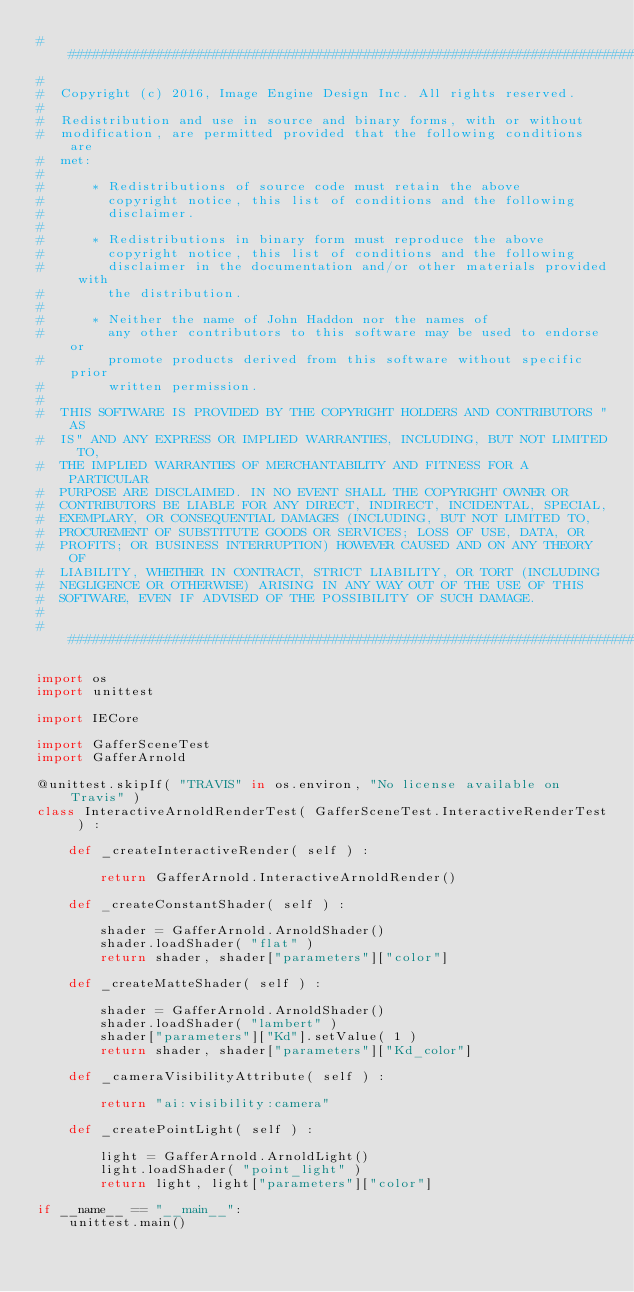<code> <loc_0><loc_0><loc_500><loc_500><_Python_>##########################################################################
#
#  Copyright (c) 2016, Image Engine Design Inc. All rights reserved.
#
#  Redistribution and use in source and binary forms, with or without
#  modification, are permitted provided that the following conditions are
#  met:
#
#      * Redistributions of source code must retain the above
#        copyright notice, this list of conditions and the following
#        disclaimer.
#
#      * Redistributions in binary form must reproduce the above
#        copyright notice, this list of conditions and the following
#        disclaimer in the documentation and/or other materials provided with
#        the distribution.
#
#      * Neither the name of John Haddon nor the names of
#        any other contributors to this software may be used to endorse or
#        promote products derived from this software without specific prior
#        written permission.
#
#  THIS SOFTWARE IS PROVIDED BY THE COPYRIGHT HOLDERS AND CONTRIBUTORS "AS
#  IS" AND ANY EXPRESS OR IMPLIED WARRANTIES, INCLUDING, BUT NOT LIMITED TO,
#  THE IMPLIED WARRANTIES OF MERCHANTABILITY AND FITNESS FOR A PARTICULAR
#  PURPOSE ARE DISCLAIMED. IN NO EVENT SHALL THE COPYRIGHT OWNER OR
#  CONTRIBUTORS BE LIABLE FOR ANY DIRECT, INDIRECT, INCIDENTAL, SPECIAL,
#  EXEMPLARY, OR CONSEQUENTIAL DAMAGES (INCLUDING, BUT NOT LIMITED TO,
#  PROCUREMENT OF SUBSTITUTE GOODS OR SERVICES; LOSS OF USE, DATA, OR
#  PROFITS; OR BUSINESS INTERRUPTION) HOWEVER CAUSED AND ON ANY THEORY OF
#  LIABILITY, WHETHER IN CONTRACT, STRICT LIABILITY, OR TORT (INCLUDING
#  NEGLIGENCE OR OTHERWISE) ARISING IN ANY WAY OUT OF THE USE OF THIS
#  SOFTWARE, EVEN IF ADVISED OF THE POSSIBILITY OF SUCH DAMAGE.
#
##########################################################################

import os
import unittest

import IECore

import GafferSceneTest
import GafferArnold

@unittest.skipIf( "TRAVIS" in os.environ, "No license available on Travis" )
class InteractiveArnoldRenderTest( GafferSceneTest.InteractiveRenderTest ) :

	def _createInteractiveRender( self ) :

		return GafferArnold.InteractiveArnoldRender()

	def _createConstantShader( self ) :

		shader = GafferArnold.ArnoldShader()
		shader.loadShader( "flat" )
		return shader, shader["parameters"]["color"]

	def _createMatteShader( self ) :

		shader = GafferArnold.ArnoldShader()
		shader.loadShader( "lambert" )
		shader["parameters"]["Kd"].setValue( 1 )
		return shader, shader["parameters"]["Kd_color"]

	def _cameraVisibilityAttribute( self ) :

		return "ai:visibility:camera"

	def _createPointLight( self ) :

		light = GafferArnold.ArnoldLight()
		light.loadShader( "point_light" )
		return light, light["parameters"]["color"]

if __name__ == "__main__":
	unittest.main()
</code> 